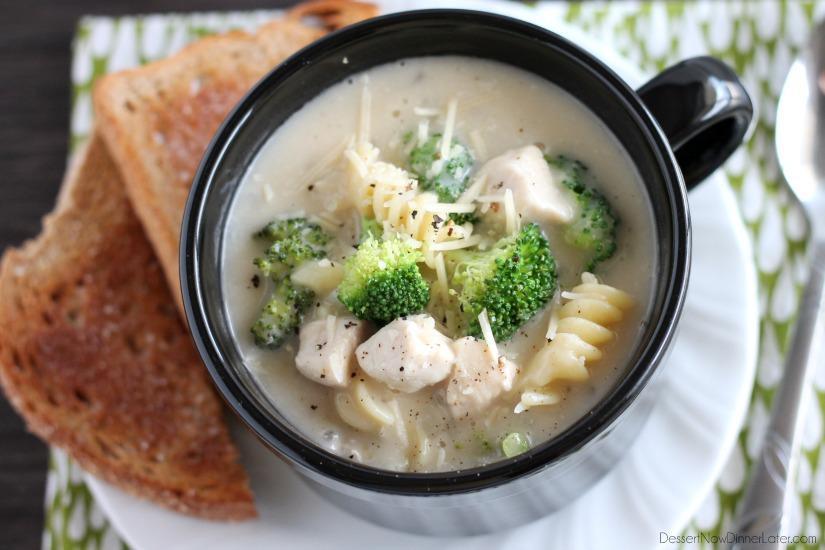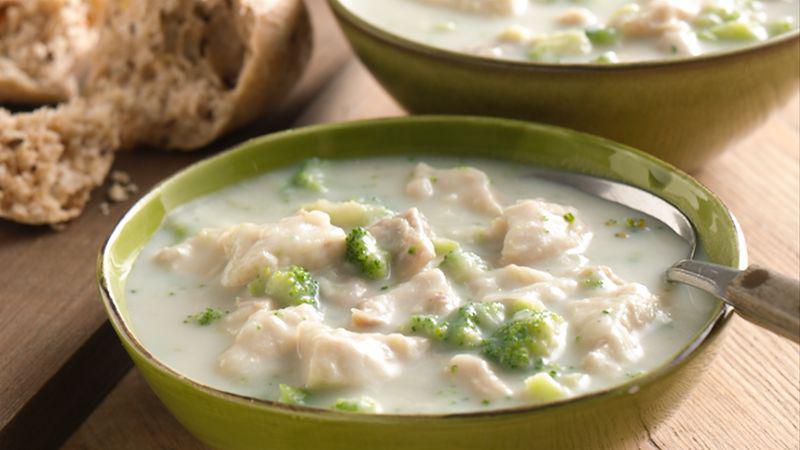The first image is the image on the left, the second image is the image on the right. Analyze the images presented: Is the assertion "There is a white plate beneath the soup in the image on the left." valid? Answer yes or no. Yes. 